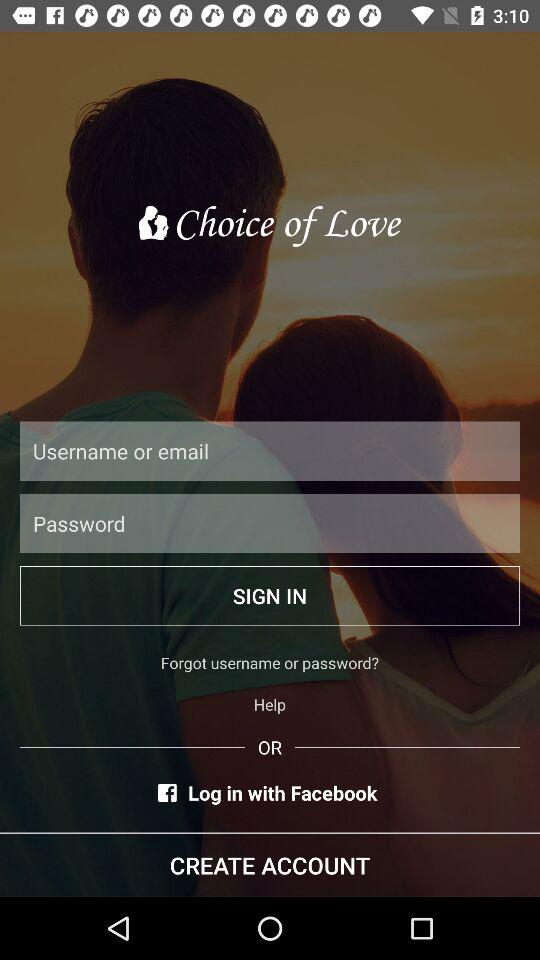How many text inputs are there for logging in?
Answer the question using a single word or phrase. 2 